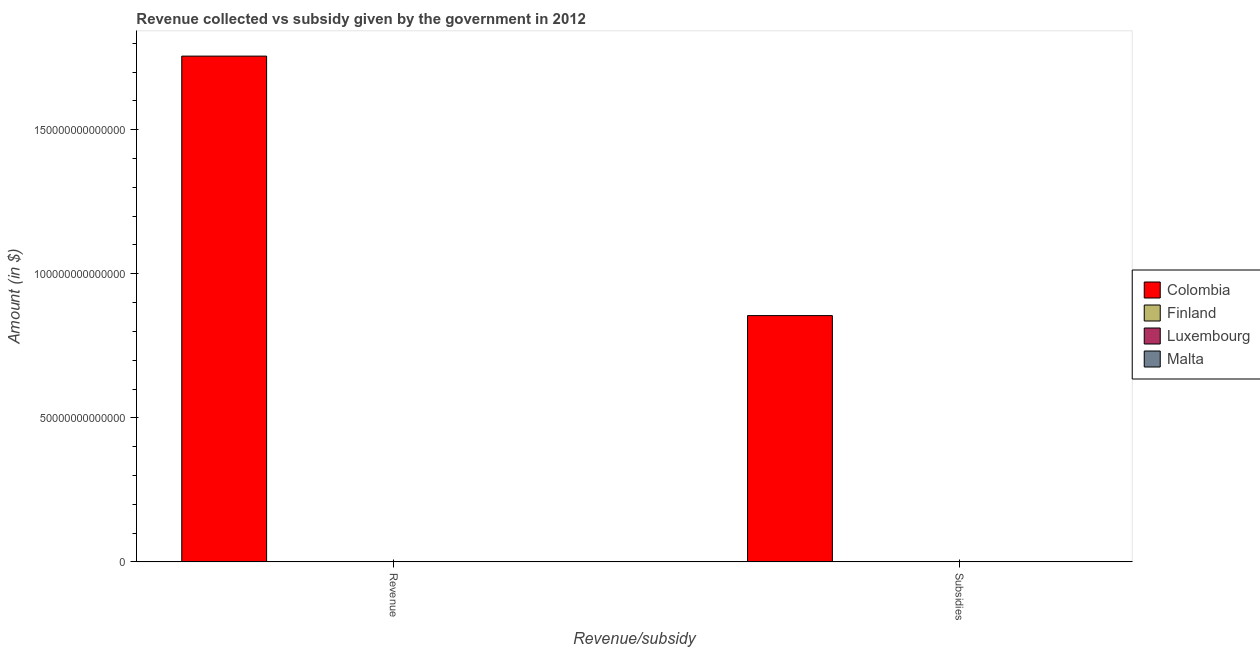How many groups of bars are there?
Keep it short and to the point. 2. Are the number of bars on each tick of the X-axis equal?
Offer a terse response. Yes. How many bars are there on the 2nd tick from the right?
Give a very brief answer. 4. What is the label of the 2nd group of bars from the left?
Your response must be concise. Subsidies. What is the amount of subsidies given in Colombia?
Give a very brief answer. 8.55e+13. Across all countries, what is the maximum amount of subsidies given?
Provide a succinct answer. 8.55e+13. Across all countries, what is the minimum amount of revenue collected?
Provide a short and direct response. 2.57e+09. In which country was the amount of revenue collected minimum?
Ensure brevity in your answer.  Malta. What is the total amount of revenue collected in the graph?
Offer a terse response. 1.76e+14. What is the difference between the amount of revenue collected in Colombia and that in Finland?
Your answer should be very brief. 1.75e+14. What is the difference between the amount of subsidies given in Colombia and the amount of revenue collected in Luxembourg?
Provide a short and direct response. 8.55e+13. What is the average amount of subsidies given per country?
Offer a very short reply. 2.14e+13. What is the difference between the amount of subsidies given and amount of revenue collected in Luxembourg?
Ensure brevity in your answer.  -5.57e+09. What is the ratio of the amount of subsidies given in Colombia to that in Malta?
Make the answer very short. 7.88e+04. In how many countries, is the amount of subsidies given greater than the average amount of subsidies given taken over all countries?
Your response must be concise. 1. What does the 4th bar from the left in Subsidies represents?
Keep it short and to the point. Malta. What is the difference between two consecutive major ticks on the Y-axis?
Keep it short and to the point. 5.00e+13. Are the values on the major ticks of Y-axis written in scientific E-notation?
Your answer should be very brief. No. Does the graph contain any zero values?
Your answer should be compact. No. Does the graph contain grids?
Keep it short and to the point. No. How many legend labels are there?
Your answer should be compact. 4. How are the legend labels stacked?
Your answer should be compact. Vertical. What is the title of the graph?
Offer a terse response. Revenue collected vs subsidy given by the government in 2012. What is the label or title of the X-axis?
Your response must be concise. Revenue/subsidy. What is the label or title of the Y-axis?
Provide a short and direct response. Amount (in $). What is the Amount (in $) in Colombia in Revenue?
Ensure brevity in your answer.  1.76e+14. What is the Amount (in $) of Finland in Revenue?
Make the answer very short. 7.44e+1. What is the Amount (in $) in Luxembourg in Revenue?
Keep it short and to the point. 1.76e+1. What is the Amount (in $) in Malta in Revenue?
Your answer should be compact. 2.57e+09. What is the Amount (in $) in Colombia in Subsidies?
Offer a terse response. 8.55e+13. What is the Amount (in $) of Finland in Subsidies?
Your answer should be compact. 5.50e+1. What is the Amount (in $) in Luxembourg in Subsidies?
Provide a short and direct response. 1.20e+1. What is the Amount (in $) of Malta in Subsidies?
Give a very brief answer. 1.09e+09. Across all Revenue/subsidy, what is the maximum Amount (in $) in Colombia?
Your answer should be compact. 1.76e+14. Across all Revenue/subsidy, what is the maximum Amount (in $) in Finland?
Keep it short and to the point. 7.44e+1. Across all Revenue/subsidy, what is the maximum Amount (in $) in Luxembourg?
Your response must be concise. 1.76e+1. Across all Revenue/subsidy, what is the maximum Amount (in $) of Malta?
Offer a terse response. 2.57e+09. Across all Revenue/subsidy, what is the minimum Amount (in $) in Colombia?
Keep it short and to the point. 8.55e+13. Across all Revenue/subsidy, what is the minimum Amount (in $) of Finland?
Make the answer very short. 5.50e+1. Across all Revenue/subsidy, what is the minimum Amount (in $) of Luxembourg?
Ensure brevity in your answer.  1.20e+1. Across all Revenue/subsidy, what is the minimum Amount (in $) of Malta?
Provide a succinct answer. 1.09e+09. What is the total Amount (in $) in Colombia in the graph?
Provide a succinct answer. 2.61e+14. What is the total Amount (in $) in Finland in the graph?
Provide a short and direct response. 1.29e+11. What is the total Amount (in $) of Luxembourg in the graph?
Offer a terse response. 2.96e+1. What is the total Amount (in $) in Malta in the graph?
Keep it short and to the point. 3.65e+09. What is the difference between the Amount (in $) of Colombia in Revenue and that in Subsidies?
Your answer should be very brief. 9.01e+13. What is the difference between the Amount (in $) in Finland in Revenue and that in Subsidies?
Provide a succinct answer. 1.94e+1. What is the difference between the Amount (in $) in Luxembourg in Revenue and that in Subsidies?
Provide a short and direct response. 5.57e+09. What is the difference between the Amount (in $) in Malta in Revenue and that in Subsidies?
Give a very brief answer. 1.48e+09. What is the difference between the Amount (in $) of Colombia in Revenue and the Amount (in $) of Finland in Subsidies?
Offer a very short reply. 1.75e+14. What is the difference between the Amount (in $) of Colombia in Revenue and the Amount (in $) of Luxembourg in Subsidies?
Make the answer very short. 1.76e+14. What is the difference between the Amount (in $) in Colombia in Revenue and the Amount (in $) in Malta in Subsidies?
Make the answer very short. 1.76e+14. What is the difference between the Amount (in $) of Finland in Revenue and the Amount (in $) of Luxembourg in Subsidies?
Give a very brief answer. 6.24e+1. What is the difference between the Amount (in $) in Finland in Revenue and the Amount (in $) in Malta in Subsidies?
Ensure brevity in your answer.  7.33e+1. What is the difference between the Amount (in $) of Luxembourg in Revenue and the Amount (in $) of Malta in Subsidies?
Give a very brief answer. 1.65e+1. What is the average Amount (in $) of Colombia per Revenue/subsidy?
Make the answer very short. 1.31e+14. What is the average Amount (in $) in Finland per Revenue/subsidy?
Provide a short and direct response. 6.47e+1. What is the average Amount (in $) of Luxembourg per Revenue/subsidy?
Your answer should be very brief. 1.48e+1. What is the average Amount (in $) in Malta per Revenue/subsidy?
Keep it short and to the point. 1.83e+09. What is the difference between the Amount (in $) of Colombia and Amount (in $) of Finland in Revenue?
Ensure brevity in your answer.  1.75e+14. What is the difference between the Amount (in $) in Colombia and Amount (in $) in Luxembourg in Revenue?
Keep it short and to the point. 1.76e+14. What is the difference between the Amount (in $) of Colombia and Amount (in $) of Malta in Revenue?
Provide a succinct answer. 1.76e+14. What is the difference between the Amount (in $) in Finland and Amount (in $) in Luxembourg in Revenue?
Offer a very short reply. 5.68e+1. What is the difference between the Amount (in $) of Finland and Amount (in $) of Malta in Revenue?
Provide a short and direct response. 7.18e+1. What is the difference between the Amount (in $) of Luxembourg and Amount (in $) of Malta in Revenue?
Offer a terse response. 1.50e+1. What is the difference between the Amount (in $) in Colombia and Amount (in $) in Finland in Subsidies?
Provide a succinct answer. 8.54e+13. What is the difference between the Amount (in $) of Colombia and Amount (in $) of Luxembourg in Subsidies?
Offer a terse response. 8.55e+13. What is the difference between the Amount (in $) in Colombia and Amount (in $) in Malta in Subsidies?
Make the answer very short. 8.55e+13. What is the difference between the Amount (in $) in Finland and Amount (in $) in Luxembourg in Subsidies?
Offer a terse response. 4.30e+1. What is the difference between the Amount (in $) of Finland and Amount (in $) of Malta in Subsidies?
Offer a terse response. 5.39e+1. What is the difference between the Amount (in $) of Luxembourg and Amount (in $) of Malta in Subsidies?
Provide a short and direct response. 1.09e+1. What is the ratio of the Amount (in $) of Colombia in Revenue to that in Subsidies?
Offer a terse response. 2.05. What is the ratio of the Amount (in $) in Finland in Revenue to that in Subsidies?
Offer a terse response. 1.35. What is the ratio of the Amount (in $) of Luxembourg in Revenue to that in Subsidies?
Keep it short and to the point. 1.46. What is the ratio of the Amount (in $) of Malta in Revenue to that in Subsidies?
Your answer should be very brief. 2.37. What is the difference between the highest and the second highest Amount (in $) of Colombia?
Keep it short and to the point. 9.01e+13. What is the difference between the highest and the second highest Amount (in $) of Finland?
Provide a succinct answer. 1.94e+1. What is the difference between the highest and the second highest Amount (in $) of Luxembourg?
Offer a very short reply. 5.57e+09. What is the difference between the highest and the second highest Amount (in $) of Malta?
Make the answer very short. 1.48e+09. What is the difference between the highest and the lowest Amount (in $) in Colombia?
Offer a terse response. 9.01e+13. What is the difference between the highest and the lowest Amount (in $) of Finland?
Offer a terse response. 1.94e+1. What is the difference between the highest and the lowest Amount (in $) of Luxembourg?
Your answer should be compact. 5.57e+09. What is the difference between the highest and the lowest Amount (in $) of Malta?
Your answer should be very brief. 1.48e+09. 